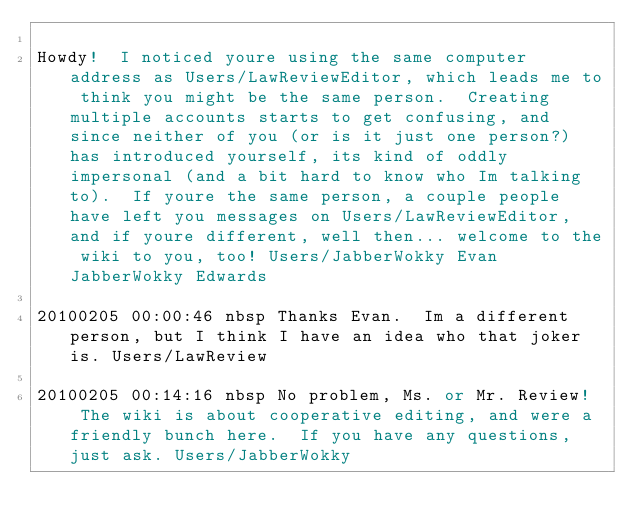<code> <loc_0><loc_0><loc_500><loc_500><_FORTRAN_>
Howdy!  I noticed youre using the same computer address as Users/LawReviewEditor, which leads me to think you might be the same person.  Creating multiple accounts starts to get confusing, and since neither of you (or is it just one person?) has introduced yourself, its kind of oddly impersonal (and a bit hard to know who Im talking to).  If youre the same person, a couple people have left you messages on Users/LawReviewEditor, and if youre different, well then... welcome to the wiki to you, too! Users/JabberWokky Evan JabberWokky Edwards

20100205 00:00:46 nbsp Thanks Evan.  Im a different person, but I think I have an idea who that joker is. Users/LawReview

20100205 00:14:16 nbsp No problem, Ms. or Mr. Review!  The wiki is about cooperative editing, and were a friendly bunch here.  If you have any questions, just ask. Users/JabberWokky
</code> 